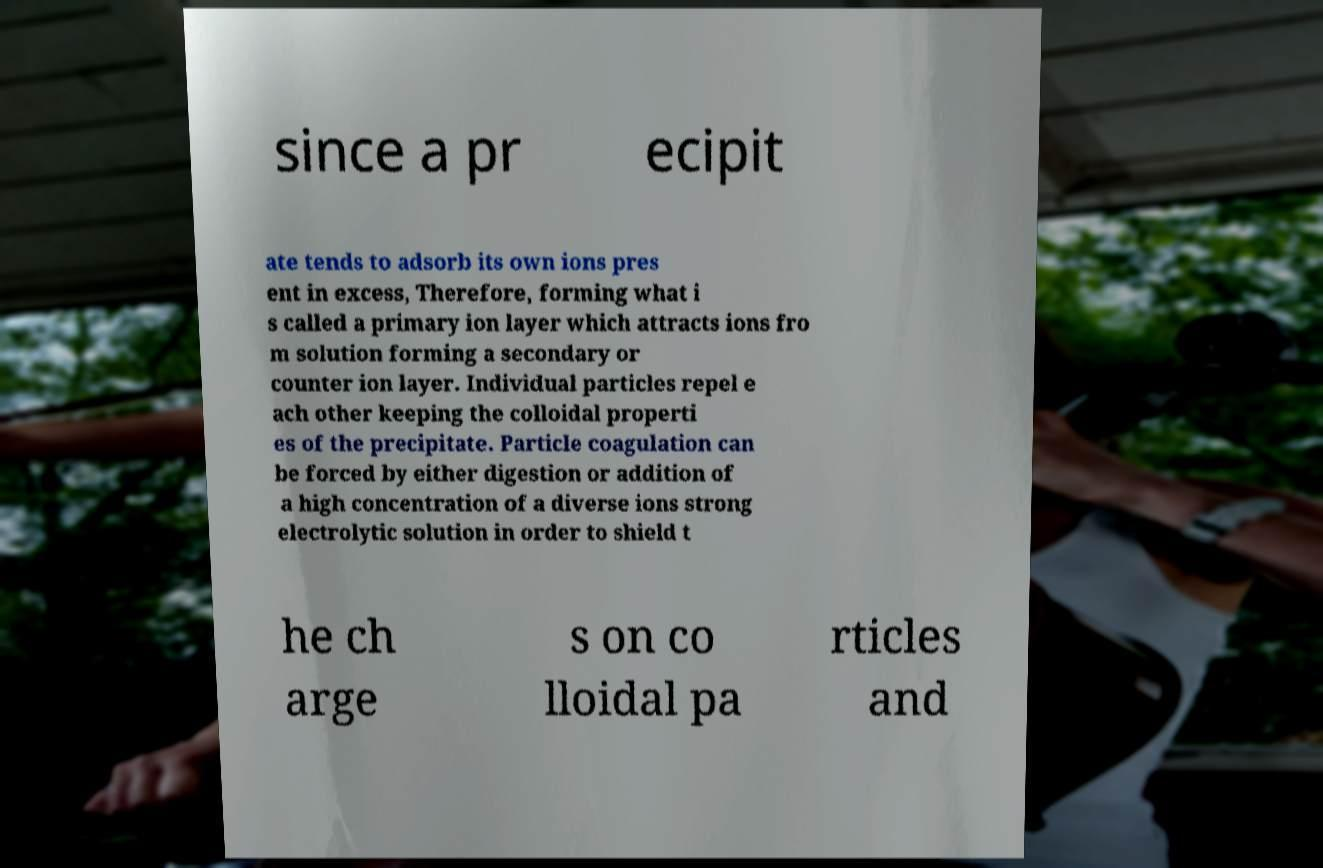I need the written content from this picture converted into text. Can you do that? since a pr ecipit ate tends to adsorb its own ions pres ent in excess, Therefore, forming what i s called a primary ion layer which attracts ions fro m solution forming a secondary or counter ion layer. Individual particles repel e ach other keeping the colloidal properti es of the precipitate. Particle coagulation can be forced by either digestion or addition of a high concentration of a diverse ions strong electrolytic solution in order to shield t he ch arge s on co lloidal pa rticles and 